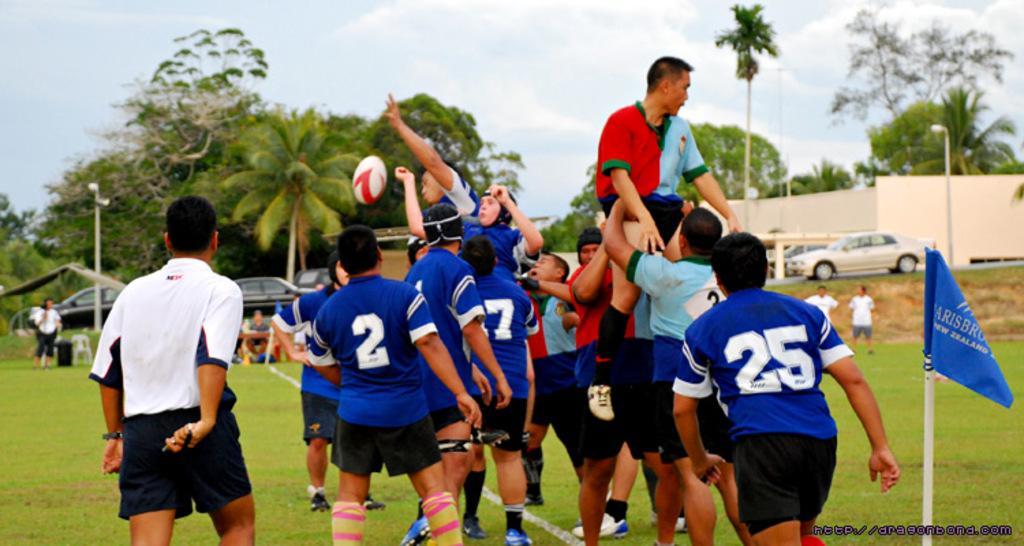Can you describe this image briefly? In this picture we can see a group of people and a flag, here we can see a ball is in the air and in the background we can see vehicles, poles, wall, trees and the sky. 